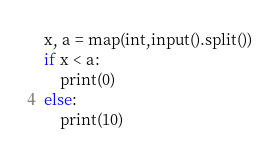<code> <loc_0><loc_0><loc_500><loc_500><_Python_>x, a = map(int,input().split())
if x < a:
    print(0)
else:
    print(10)</code> 